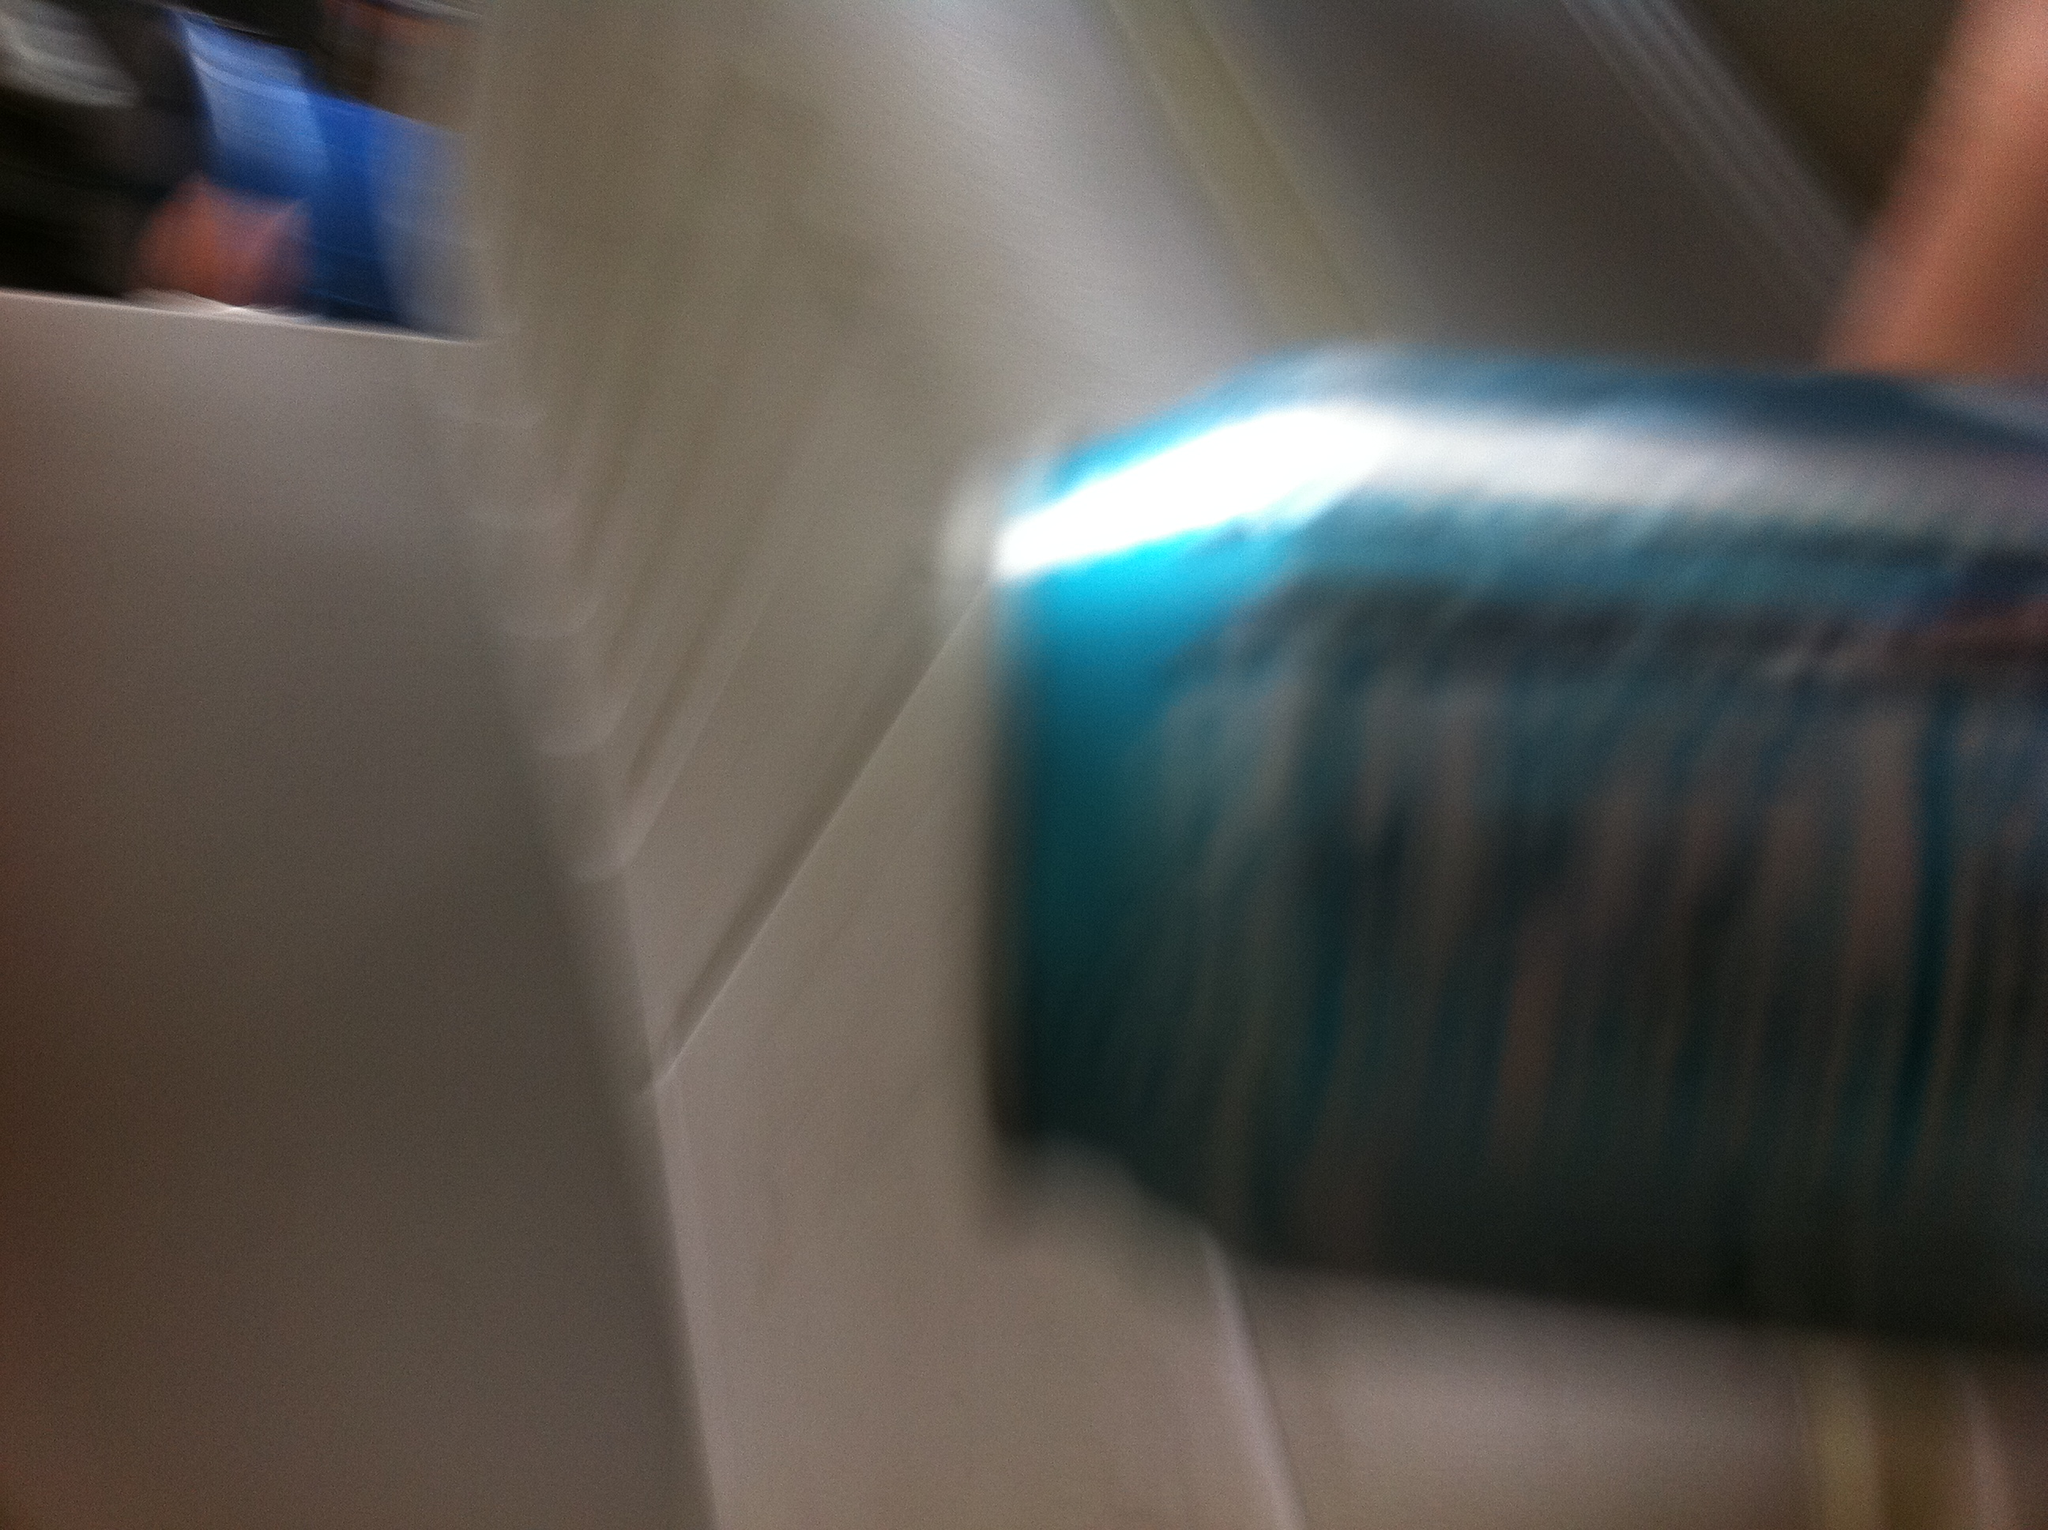Could you infer where this image might have been taken? The image appears to show a soda can in a setting that includes some geometric shapes and possibly a person in the background. This might be in a casual indoor setting like a room or a cafeteria. The blurriness suggests the photo was taken quickly or in motion. Let’s explore the mysterious background. What could be happening behind the scenes? Behind the scenes, there could be an intriguing scenario unfolding. The blurred figure in the background could be someone involved in an exciting activity or discovery. Maybe it’s a scientist rushing to document a groundbreaking experiment, or perhaps it's a friend eagerly setting up a surprise for a special occasion. The indistinct white structure might be part of a spaceship’s interior or a futuristic lab, adding a layer of mystery and excitement to the ordinary image of a soda can. Create a short realistic scenario involving this soda can. In a busy office, Sarah grabbed a can of her favorite soda during a break. As she took a sip, her colleague Mark walked by and shared some exciting news about a successful project. The blurred movement in the background captures the bustling environment of their dynamic workspace. Present a longer and more detailed realistic scenario. John, an aspiring photographer, was at the community center capturing candid moments for a local event. Amidst laughter and chatter, he quickly snapped a photo of the refreshment table where different sodas were arranged. Little did he realize, the blur in his hastily taken shot symbolized the essence of the event – a blend of energy, spontaneity, and the joy of community gatherings. Meanwhile, across the room, children played games and old friends reunited, each scene contributing to the vibrant tapestry of the day. Later, as John developed his photographs, the image of the soda can stood out to him, encapsulating the fleeting, happy moments of the event. 